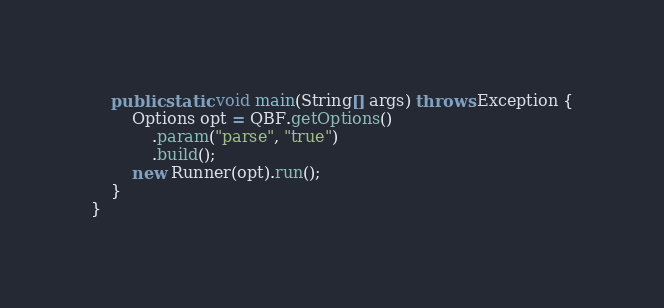<code> <loc_0><loc_0><loc_500><loc_500><_Java_>	public static void main(String[] args) throws Exception {
		Options opt = QBF.getOptions()
			.param("parse", "true")
			.build();
		new Runner(opt).run();
	}
}
</code> 